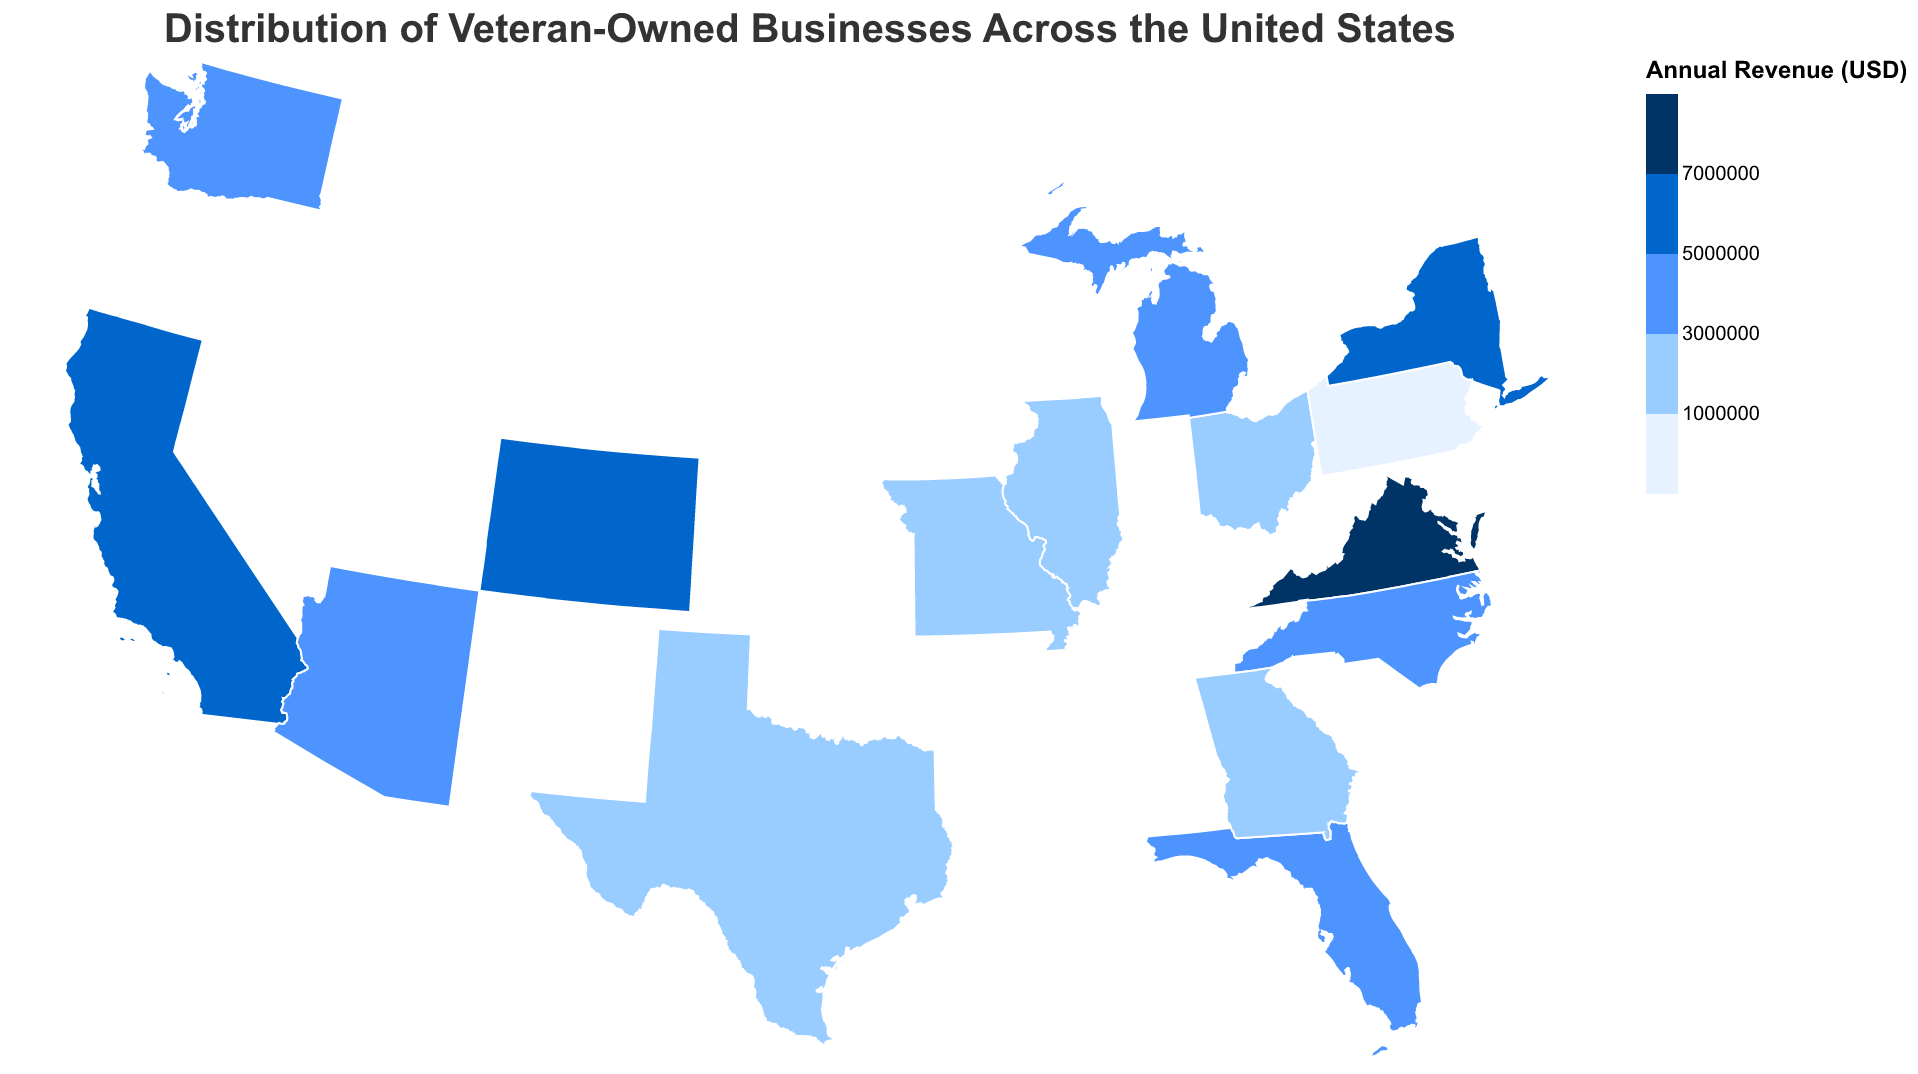What is the title of the figure? The title is displayed at the top of the plot.
Answer: Distribution of Veteran-Owned Businesses Across the United States Which state has the highest number of veteran-owned businesses in Information Technology? The tooltip specifies the number of businesses for each state and industry. The state for Information Technology with the highest number of businesses is California.
Answer: California How many veteran-owned businesses are there in Missouri? The tooltip for Missouri lists the "Number of Businesses" in that state. Missouri has 80 businesses.
Answer: 80 Compare the annual revenue of Construction in Texas and Defense Contracting in Virginia. Which one is higher? According to the tooltip, Texas (Construction) has an annual revenue of $2,500,000 and Virginia (Defense Contracting) has $7,500,000. Virginia's revenue is higher.
Answer: Virginia What is the average annual revenue of veteran-owned businesses in states with more than 100 businesses? These states are California, Texas, Florida, Virginia, Ohio, and New York. Summing their revenues: 5,000,000 + 2,500,000 + 3,000,000 + 7,500,000 + 1,200,000 + 6,500,000 = 25,700,000. Dividing by 6 gives the average.
Answer: $4,283,333 Which industry has the smallest number of veteran-owned businesses? By looking at the tooltips, Michigan (Automotive) has the smallest number with 65 businesses.
Answer: Automotive Is there any state with an annual revenue for veteran-owned businesses between 1,000,000 and 2,000,000 USD? If so, which state? The states and revenues meeting this criterion are Ohio ($1,200,000) and Missouri ($1,500,000).
Answer: Ohio and Missouri How is the color coding determined in this plot, and what does the darkest color represent? The legend shows that the colors range in shades of blue representing increasing annual revenue. The darkest color represents the highest revenue threshold, greater than or equal to $7,000,000.
Answer: Annual revenue >= $7,000,000 Which state specializes in Renewable Energy and how many veteran-owned businesses are there in that industry? The tooltip information indicates that Arizona specializes in Renewable Energy with 70 businesses in that field.
Answer: Arizona, 70 Of the states shown, which has fewer than 10 businesses more than Michigan? Michigan has 65 businesses. States having fewer than 75 (65 + 10) businesses fit this requirement. None meet exactly 10 more, but Michigan fits as it has exactly 65.
Answer: None fit exactly 10 more 